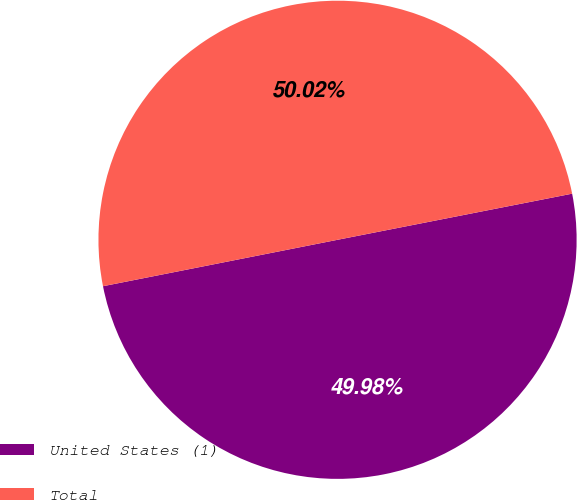Convert chart to OTSL. <chart><loc_0><loc_0><loc_500><loc_500><pie_chart><fcel>United States (1)<fcel>Total<nl><fcel>49.98%<fcel>50.02%<nl></chart> 